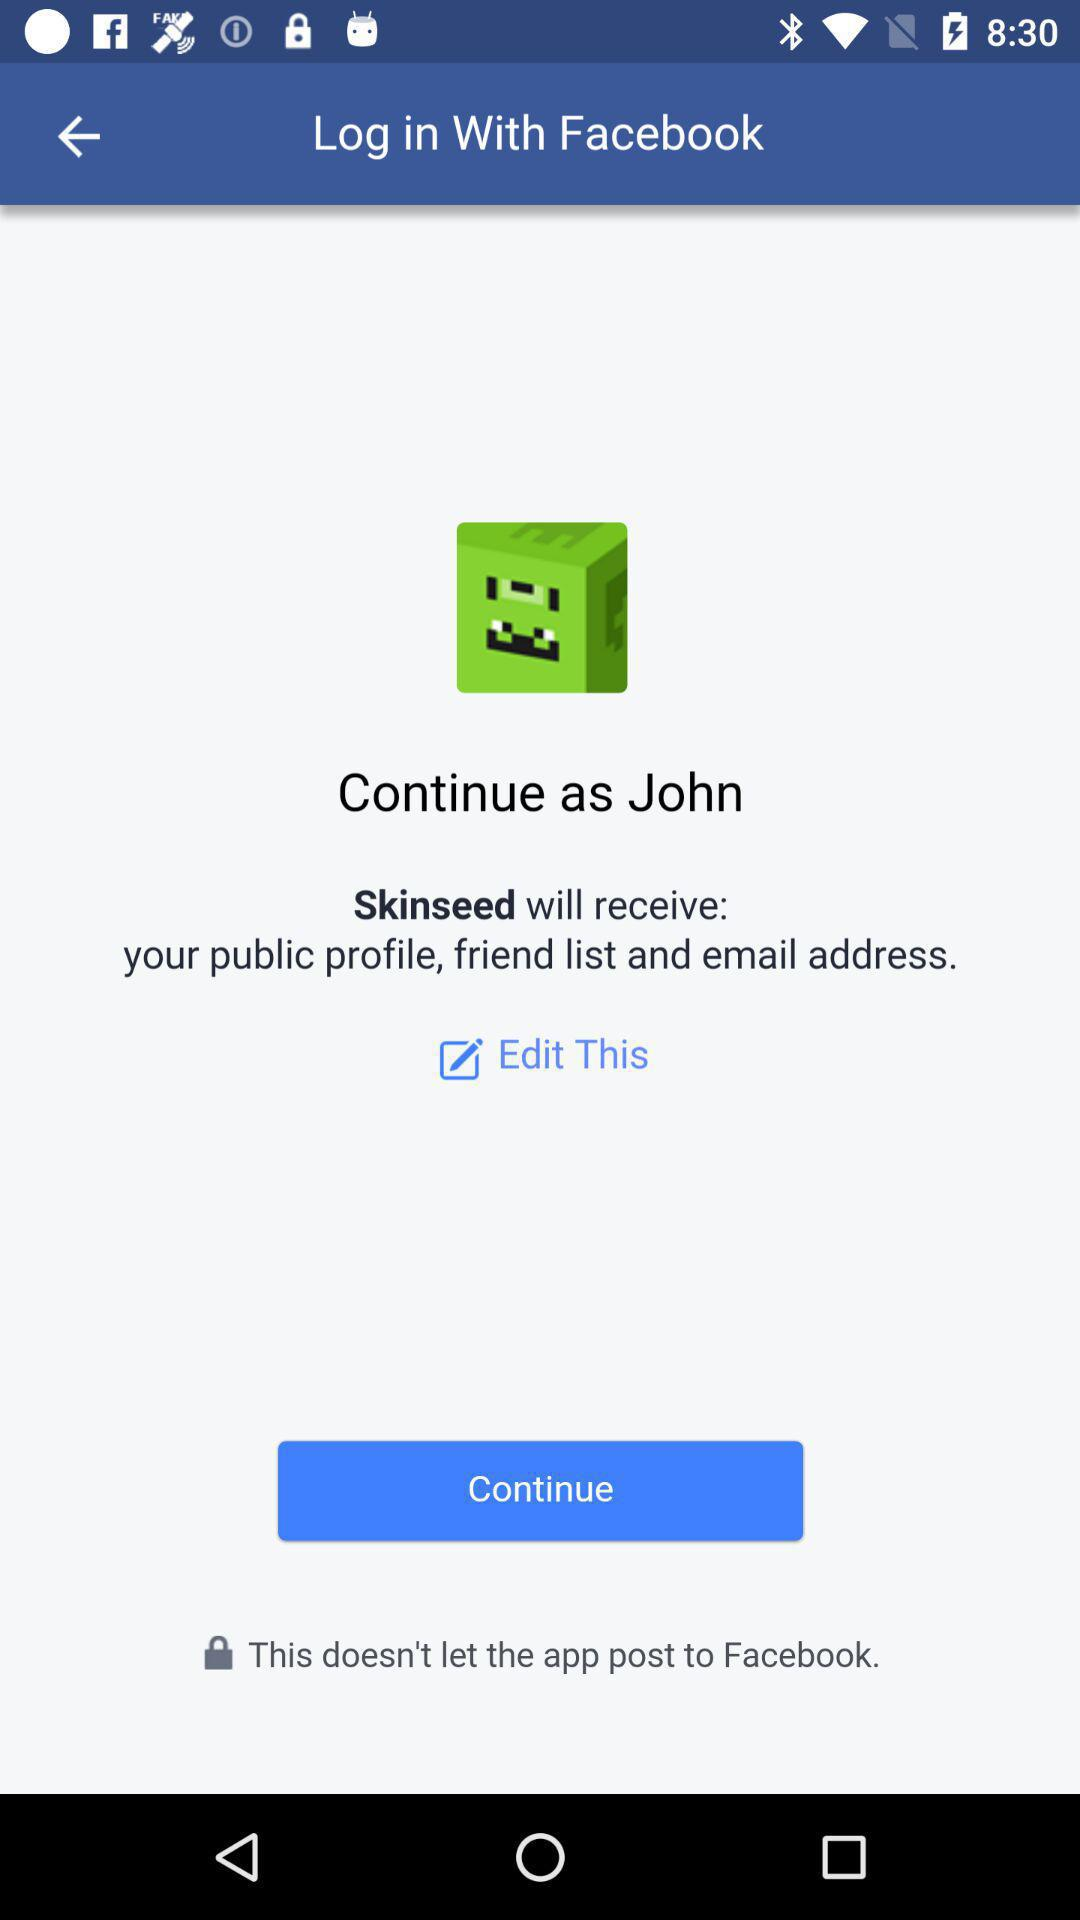What is the login name? The login name is John. 